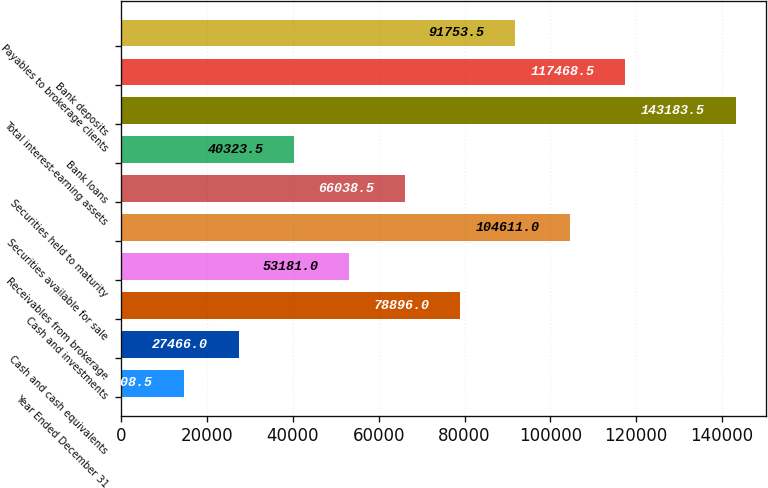Convert chart to OTSL. <chart><loc_0><loc_0><loc_500><loc_500><bar_chart><fcel>Year Ended December 31<fcel>Cash and cash equivalents<fcel>Cash and investments<fcel>Receivables from brokerage<fcel>Securities available for sale<fcel>Securities held to maturity<fcel>Bank loans<fcel>Total interest-earning assets<fcel>Bank deposits<fcel>Payables to brokerage clients<nl><fcel>14608.5<fcel>27466<fcel>78896<fcel>53181<fcel>104611<fcel>66038.5<fcel>40323.5<fcel>143184<fcel>117468<fcel>91753.5<nl></chart> 